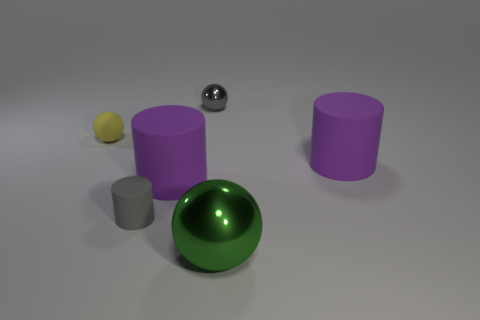There is another object that is the same color as the tiny shiny object; what is its shape?
Your answer should be very brief. Cylinder. The yellow matte object is what size?
Provide a succinct answer. Small. Is there a tiny yellow rubber thing that has the same shape as the green thing?
Offer a terse response. Yes. What number of things are either small rubber cylinders or tiny objects in front of the tiny yellow matte sphere?
Your response must be concise. 1. What color is the large cylinder that is left of the big metallic ball?
Ensure brevity in your answer.  Purple. There is a gray thing that is in front of the gray metal thing; is its size the same as the metal thing that is in front of the gray shiny sphere?
Ensure brevity in your answer.  No. Is there a yellow matte sphere of the same size as the green metallic sphere?
Provide a short and direct response. No. There is a large cylinder that is to the right of the small gray metal object; how many large purple rubber objects are in front of it?
Offer a terse response. 1. What is the small gray cylinder made of?
Provide a succinct answer. Rubber. There is a big metallic thing; what number of gray shiny things are to the left of it?
Your answer should be very brief. 1. 